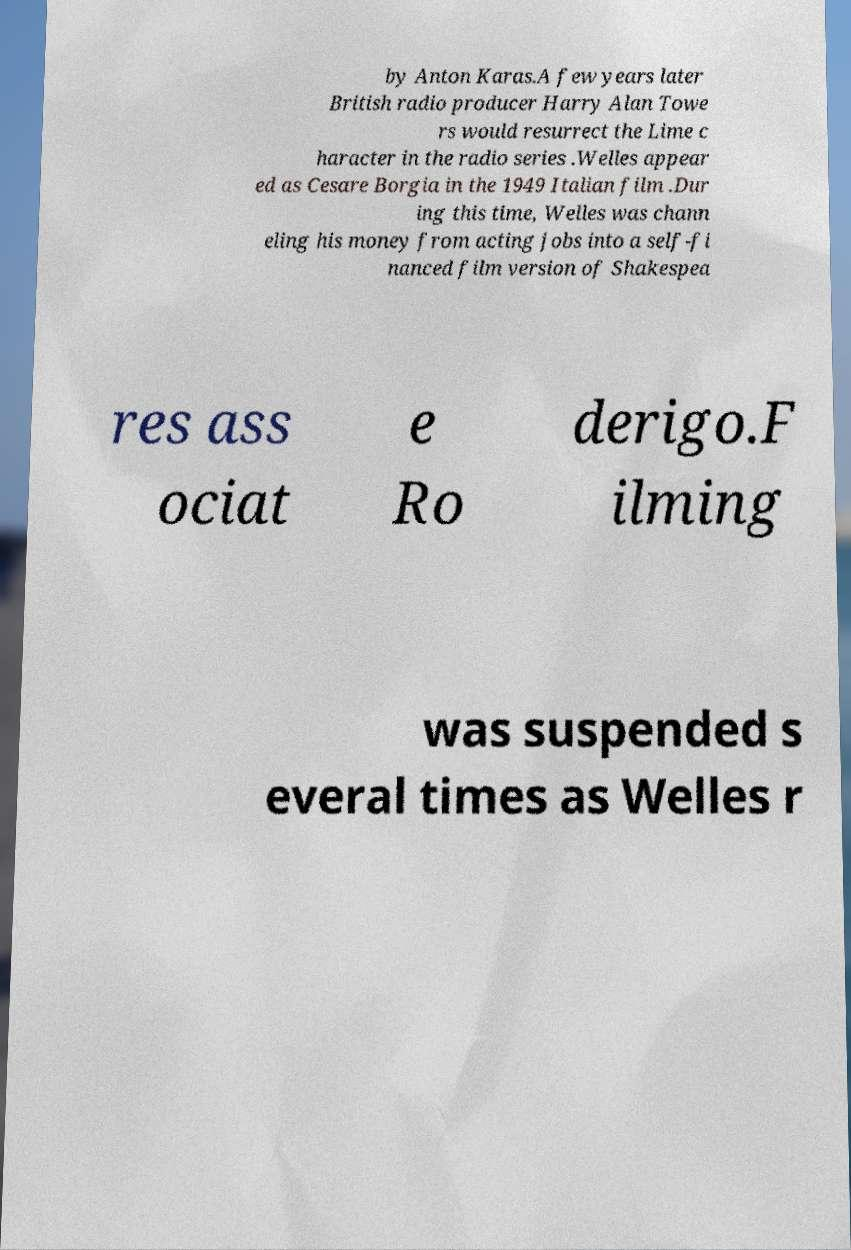Can you accurately transcribe the text from the provided image for me? by Anton Karas.A few years later British radio producer Harry Alan Towe rs would resurrect the Lime c haracter in the radio series .Welles appear ed as Cesare Borgia in the 1949 Italian film .Dur ing this time, Welles was chann eling his money from acting jobs into a self-fi nanced film version of Shakespea res ass ociat e Ro derigo.F ilming was suspended s everal times as Welles r 